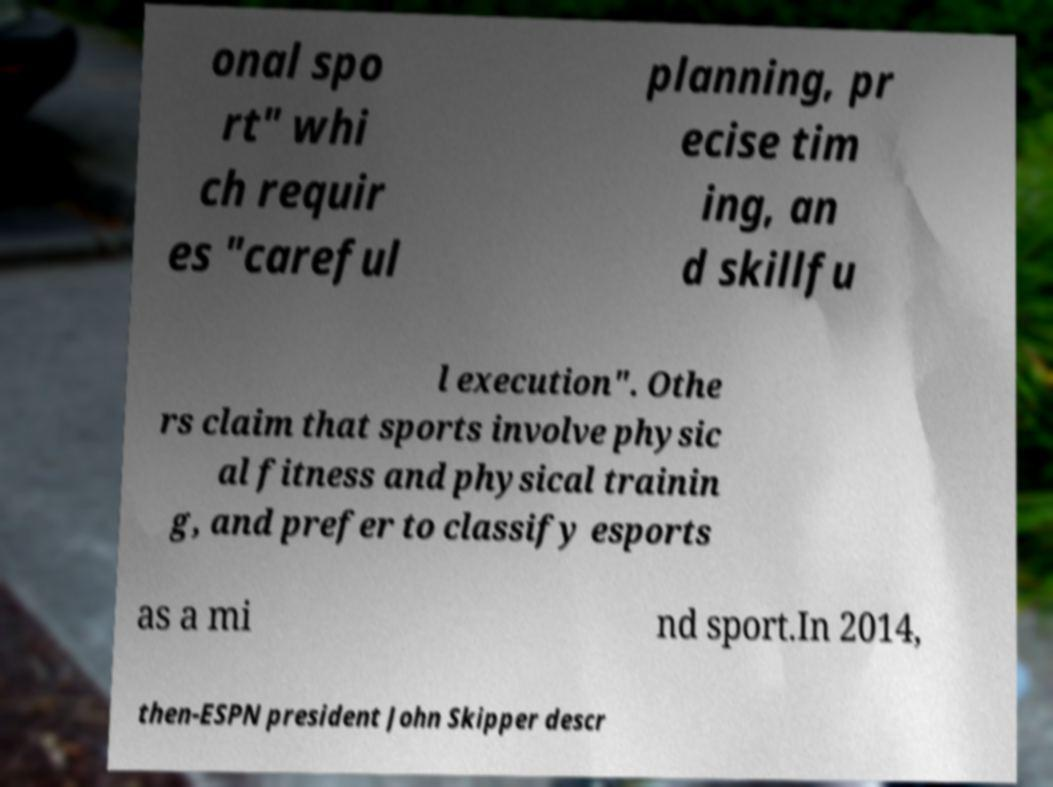I need the written content from this picture converted into text. Can you do that? onal spo rt" whi ch requir es "careful planning, pr ecise tim ing, an d skillfu l execution". Othe rs claim that sports involve physic al fitness and physical trainin g, and prefer to classify esports as a mi nd sport.In 2014, then-ESPN president John Skipper descr 